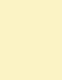Convert code to text. <code><loc_0><loc_0><loc_500><loc_500><_SQL_>
</code> 